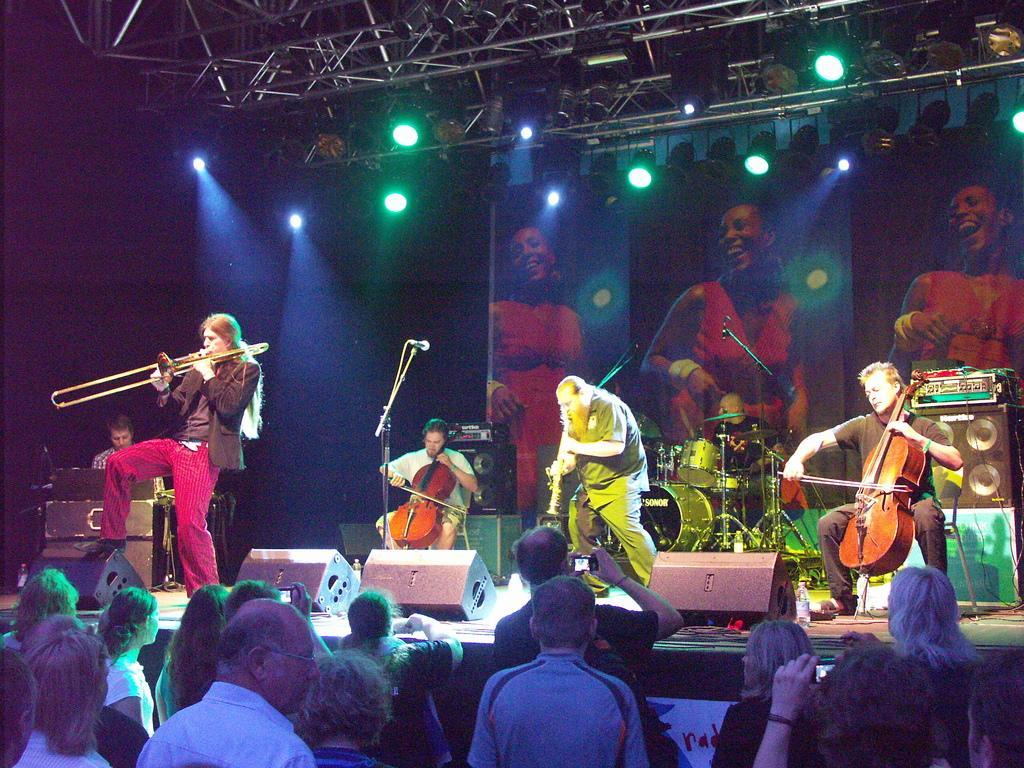In one or two sentences, can you explain what this image depicts? 4 people are performing on the stage. the person at the right is playing violin. the person at the left is playing saxophone, behind him there are drums. above him there are lights. behind them there is a banner. 